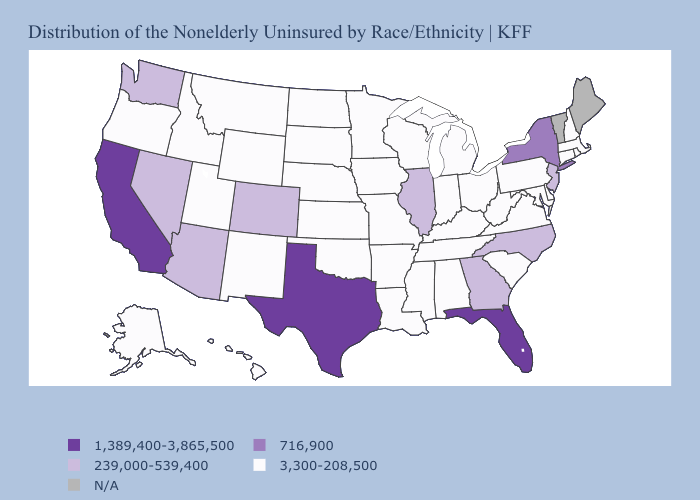Does the map have missing data?
Answer briefly. Yes. What is the highest value in the USA?
Give a very brief answer. 1,389,400-3,865,500. Which states have the highest value in the USA?
Write a very short answer. California, Florida, Texas. What is the value of North Dakota?
Quick response, please. 3,300-208,500. Name the states that have a value in the range 3,300-208,500?
Keep it brief. Alabama, Alaska, Arkansas, Connecticut, Delaware, Hawaii, Idaho, Indiana, Iowa, Kansas, Kentucky, Louisiana, Maryland, Massachusetts, Michigan, Minnesota, Mississippi, Missouri, Montana, Nebraska, New Hampshire, New Mexico, North Dakota, Ohio, Oklahoma, Oregon, Pennsylvania, Rhode Island, South Carolina, South Dakota, Tennessee, Utah, Virginia, West Virginia, Wisconsin, Wyoming. What is the value of Alaska?
Concise answer only. 3,300-208,500. What is the value of Michigan?
Be succinct. 3,300-208,500. Among the states that border Wyoming , which have the lowest value?
Write a very short answer. Idaho, Montana, Nebraska, South Dakota, Utah. What is the highest value in the USA?
Concise answer only. 1,389,400-3,865,500. Among the states that border New Mexico , does Arizona have the lowest value?
Quick response, please. No. Which states hav the highest value in the Northeast?
Short answer required. New York. What is the value of Pennsylvania?
Keep it brief. 3,300-208,500. 